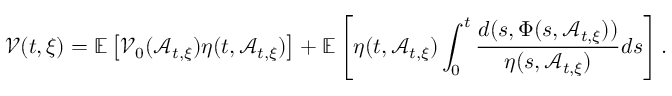Convert formula to latex. <formula><loc_0><loc_0><loc_500><loc_500>\mathcal { V } ( t , \xi ) = \mathbb { E } \left [ \mathcal { V } _ { 0 } ( \mathcal { A } _ { t , \xi } ) \eta ( t , \mathcal { A } _ { t , \xi } ) \right ] + \mathbb { E } \left [ \eta ( t , \mathcal { A } _ { t , \xi } ) \int _ { 0 } ^ { t } \frac { d ( s , \Phi ( s , \mathcal { A } _ { t , \xi } ) ) } { \eta ( s , \mathcal { A } _ { t , \xi } ) } d s \right ] .</formula> 